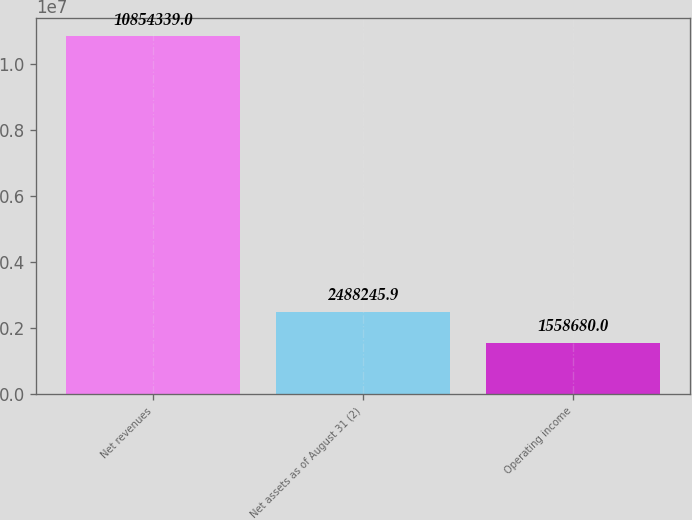Convert chart. <chart><loc_0><loc_0><loc_500><loc_500><bar_chart><fcel>Net revenues<fcel>Net assets as of August 31 (2)<fcel>Operating income<nl><fcel>1.08543e+07<fcel>2.48825e+06<fcel>1.55868e+06<nl></chart> 